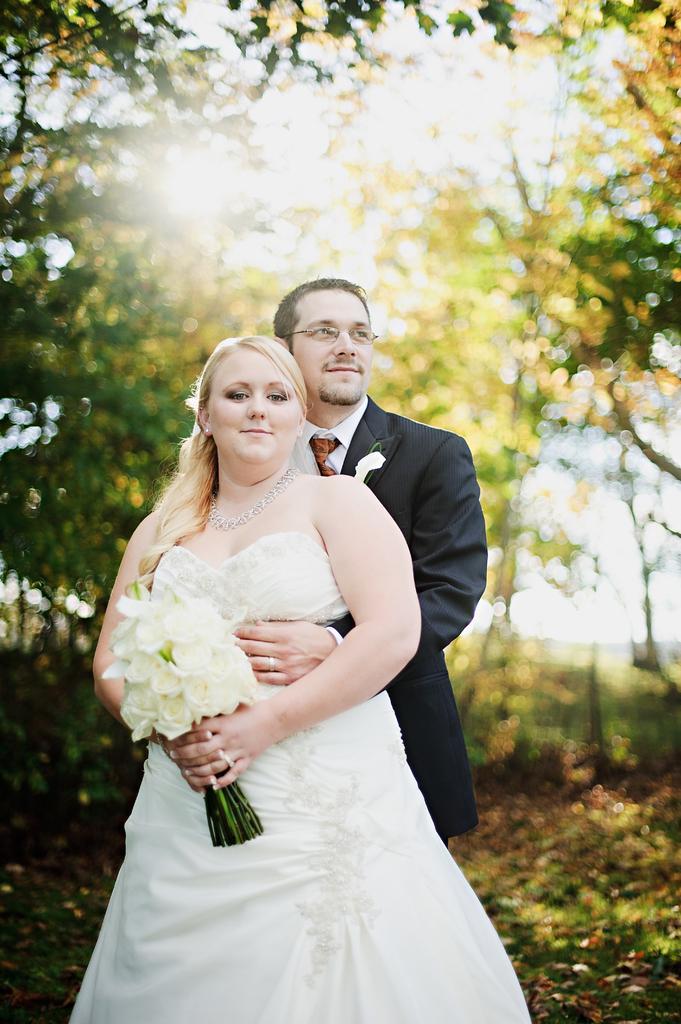Describe this image in one or two sentences. In this image I can see two people are standing and wearing black and white color dresses. One person is holding the bouquet. Back I can see few trees and the sky is in white color. 